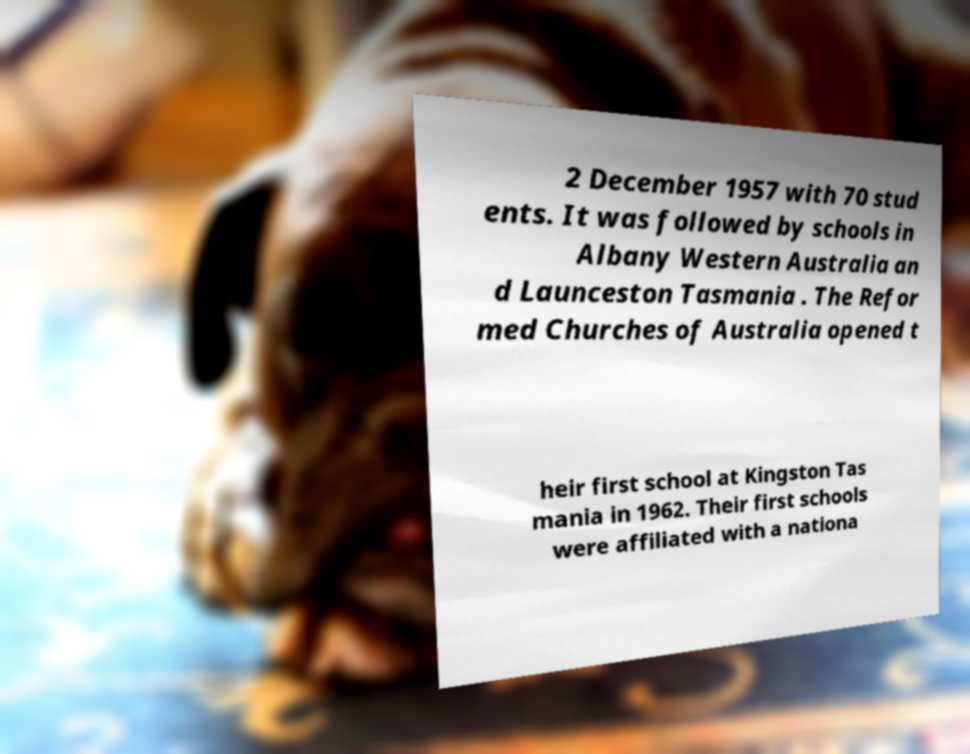For documentation purposes, I need the text within this image transcribed. Could you provide that? 2 December 1957 with 70 stud ents. It was followed by schools in Albany Western Australia an d Launceston Tasmania . The Refor med Churches of Australia opened t heir first school at Kingston Tas mania in 1962. Their first schools were affiliated with a nationa 